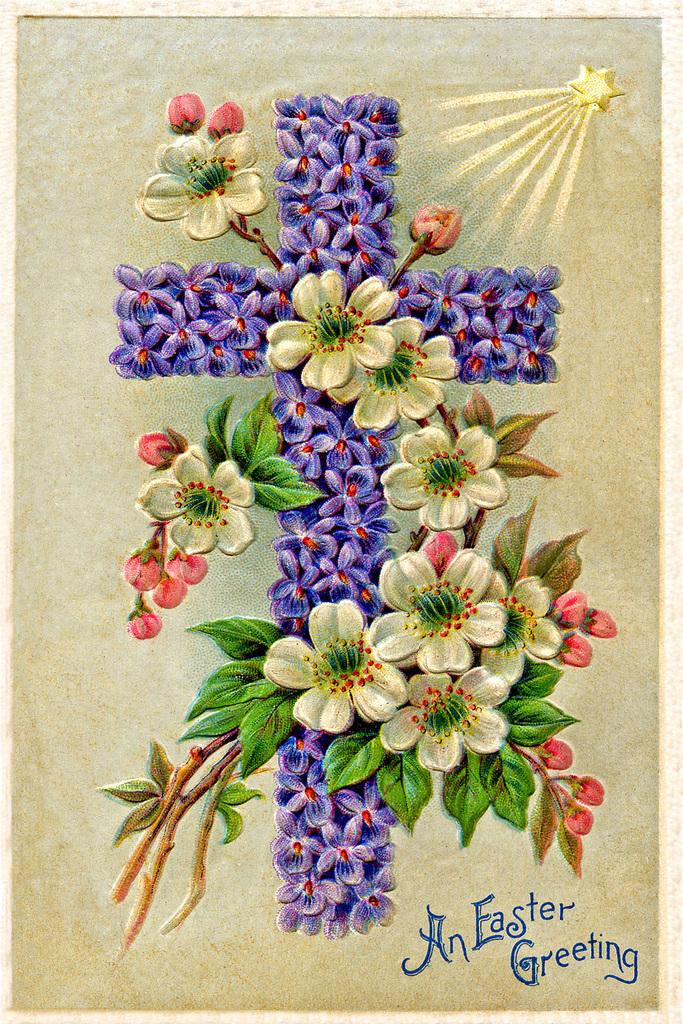What is the main subject of the image? The main subject of the image is a poster. What type of images are on the poster? The poster has images of flowers, leaves, and buds. Is there any text on the poster? Yes, there is text on the poster. What additional symbol can be seen in the image? There is a cross symbol in the image. Can you tell me how many credits are visible on the poster? There are no credits visible on the poster; it features images of flowers, leaves, and buds, along with text and a cross symbol. Is there a stream of water flowing in the image? There is no stream of water present in the image; it contains a poster with images of flowers, leaves, and buds, text, and a cross symbol. 